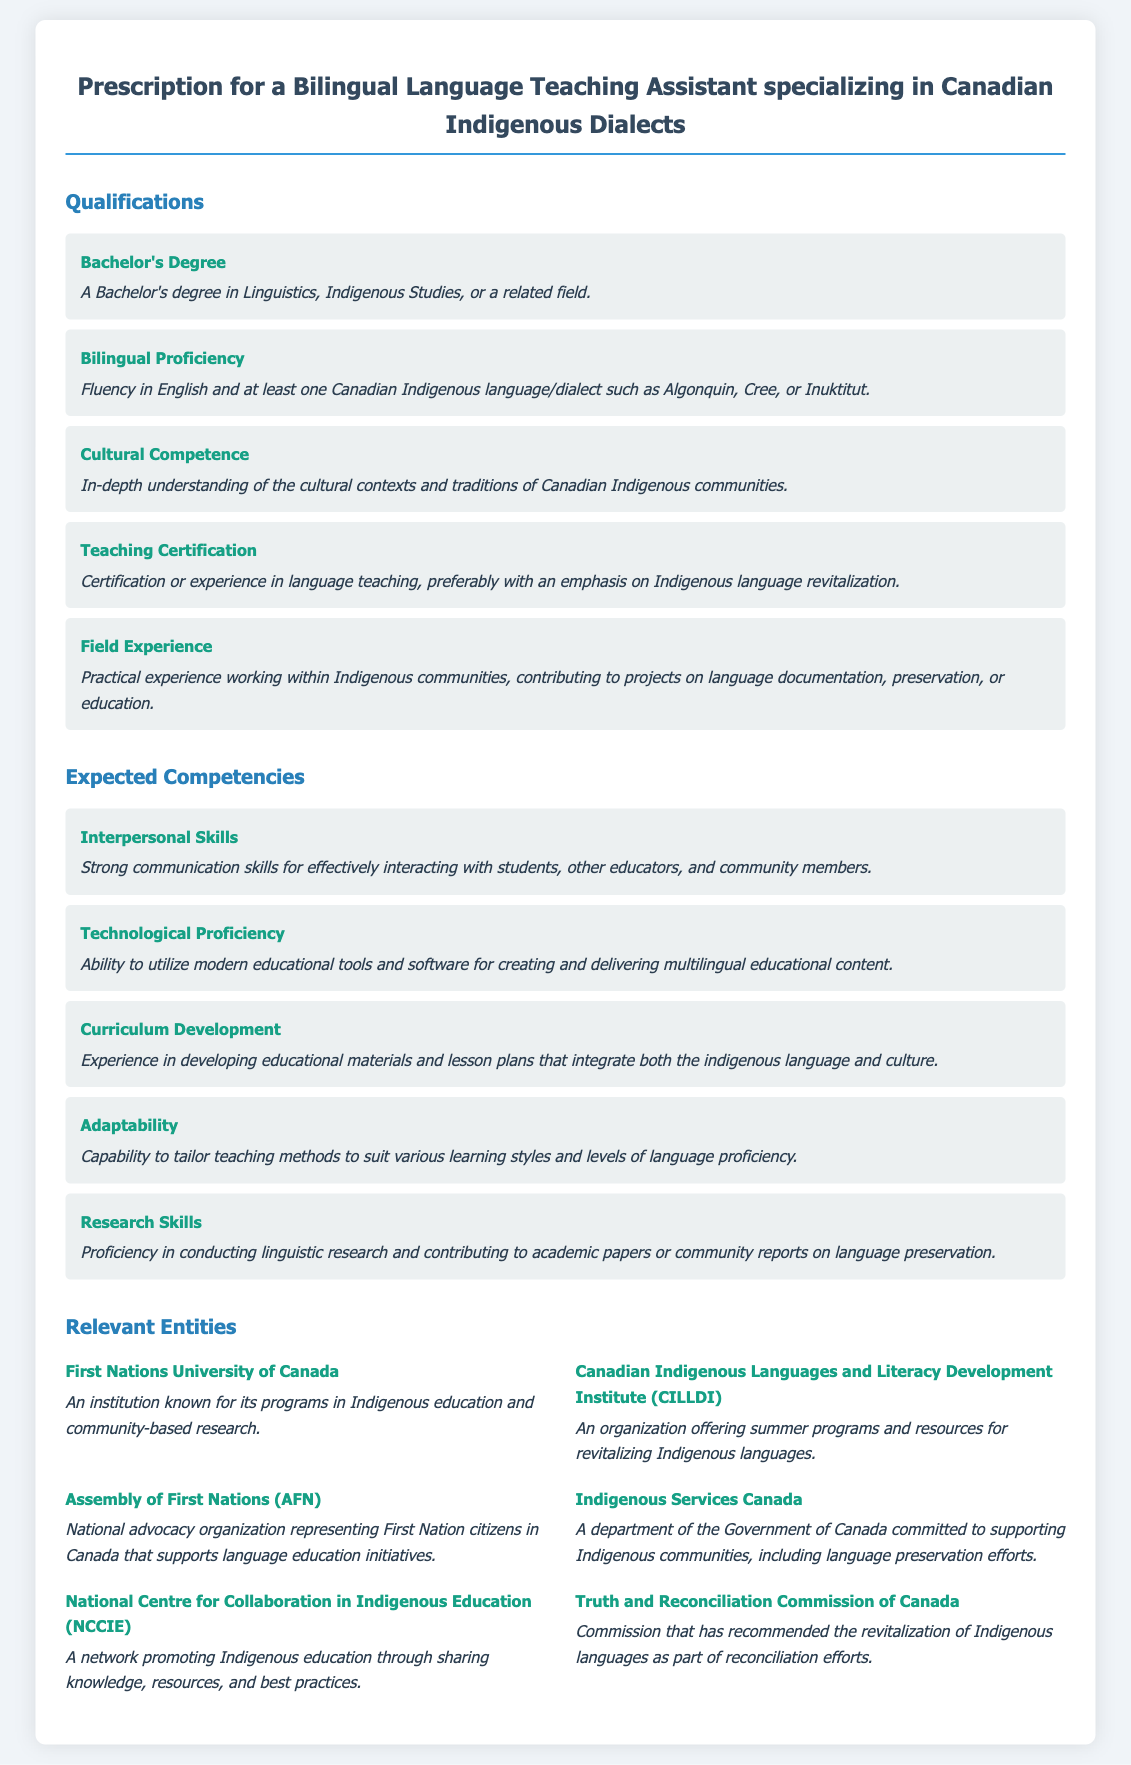What is the required degree for the position? The document specifies that a Bachelor's degree in Linguistics, Indigenous Studies, or a related field is required.
Answer: Bachelor's Degree How many Canadian Indigenous languages or dialects should the candidate be fluent in? The document states that fluency in at least one Canadian Indigenous language or dialect is needed.
Answer: One Which entity is known for Indigenous education and community-based research? The document lists the First Nations University of Canada as an institution known for these programs.
Answer: First Nations University of Canada What competency involves creating educational materials? The document specifies that Curriculum Development is the competency related to developing educational materials.
Answer: Curriculum Development What is one of the organizations mentioned that supports language education initiatives? The Assembly of First Nations is highlighted as a national advocacy organization that supports language education.
Answer: Assembly of First Nations What type of certification is preferred for teaching? The document mentions that certification or experience in language teaching is preferred, especially for Indigenous language revitalization.
Answer: Teaching Certification What is the role of the Truth and Reconciliation Commission of Canada in relation to Indigenous languages? The document states that it has recommended the revitalization of Indigenous languages as part of reconciliation efforts.
Answer: Revitalization What is a key interpersonal skill required for the position? The document emphasizes Strong communication skills as critical for effective interaction in the role.
Answer: Interpersonal Skills 